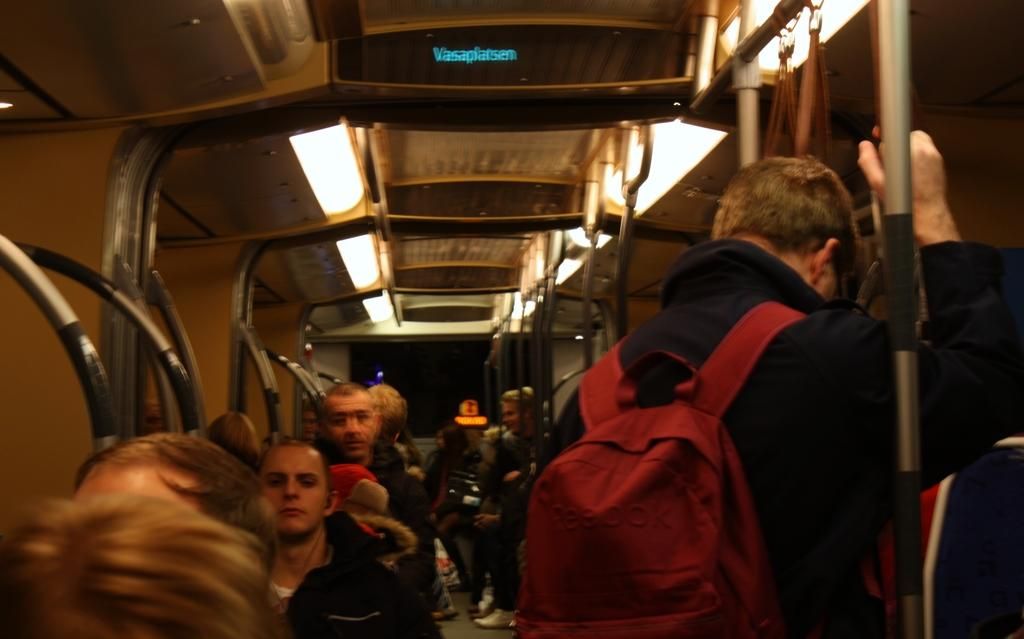What mode of transportation is shown in the image? The image is taken in a train. What are the people in the image doing? Many people are standing in the middle of the image, and they are holding poles. What part of the train can be seen in the image? There is a roof visible at the top of the image. What type of flowers can be seen growing on the train in the image? There are no flowers visible in the image; it is taken inside a train. 